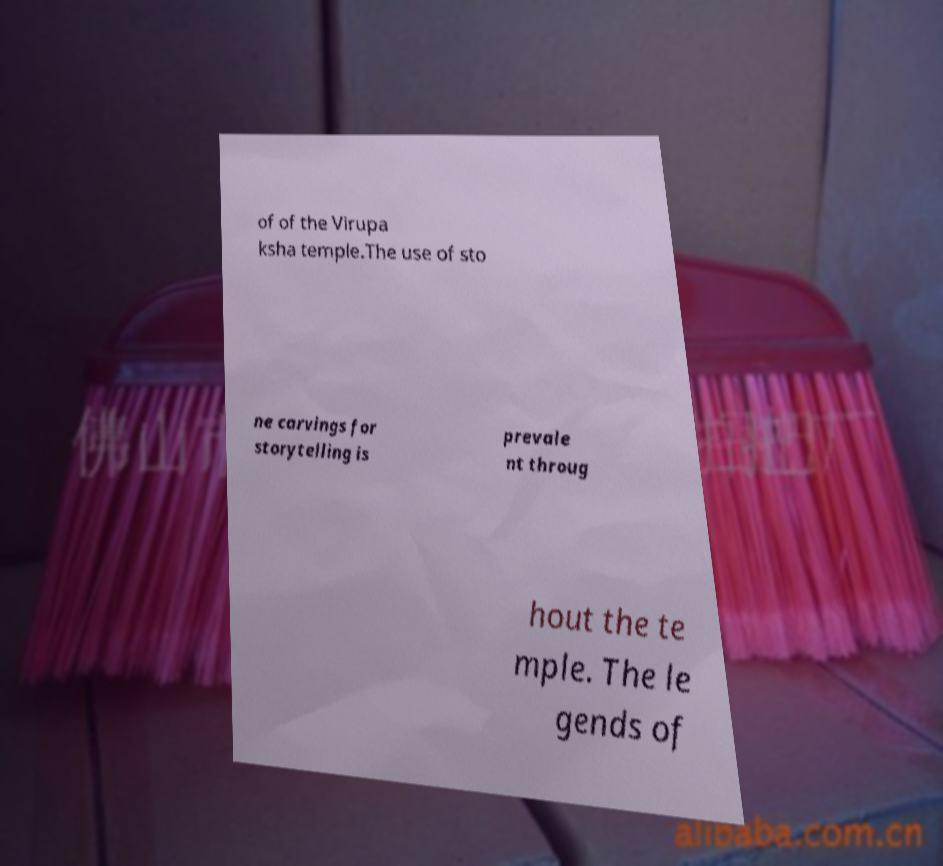Can you read and provide the text displayed in the image?This photo seems to have some interesting text. Can you extract and type it out for me? of of the Virupa ksha temple.The use of sto ne carvings for storytelling is prevale nt throug hout the te mple. The le gends of 